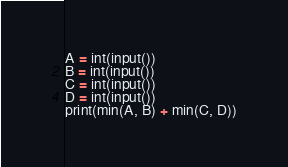<code> <loc_0><loc_0><loc_500><loc_500><_Python_>A = int(input())
B = int(input())
C = int(input())
D = int(input())
print(min(A, B) + min(C, D))</code> 